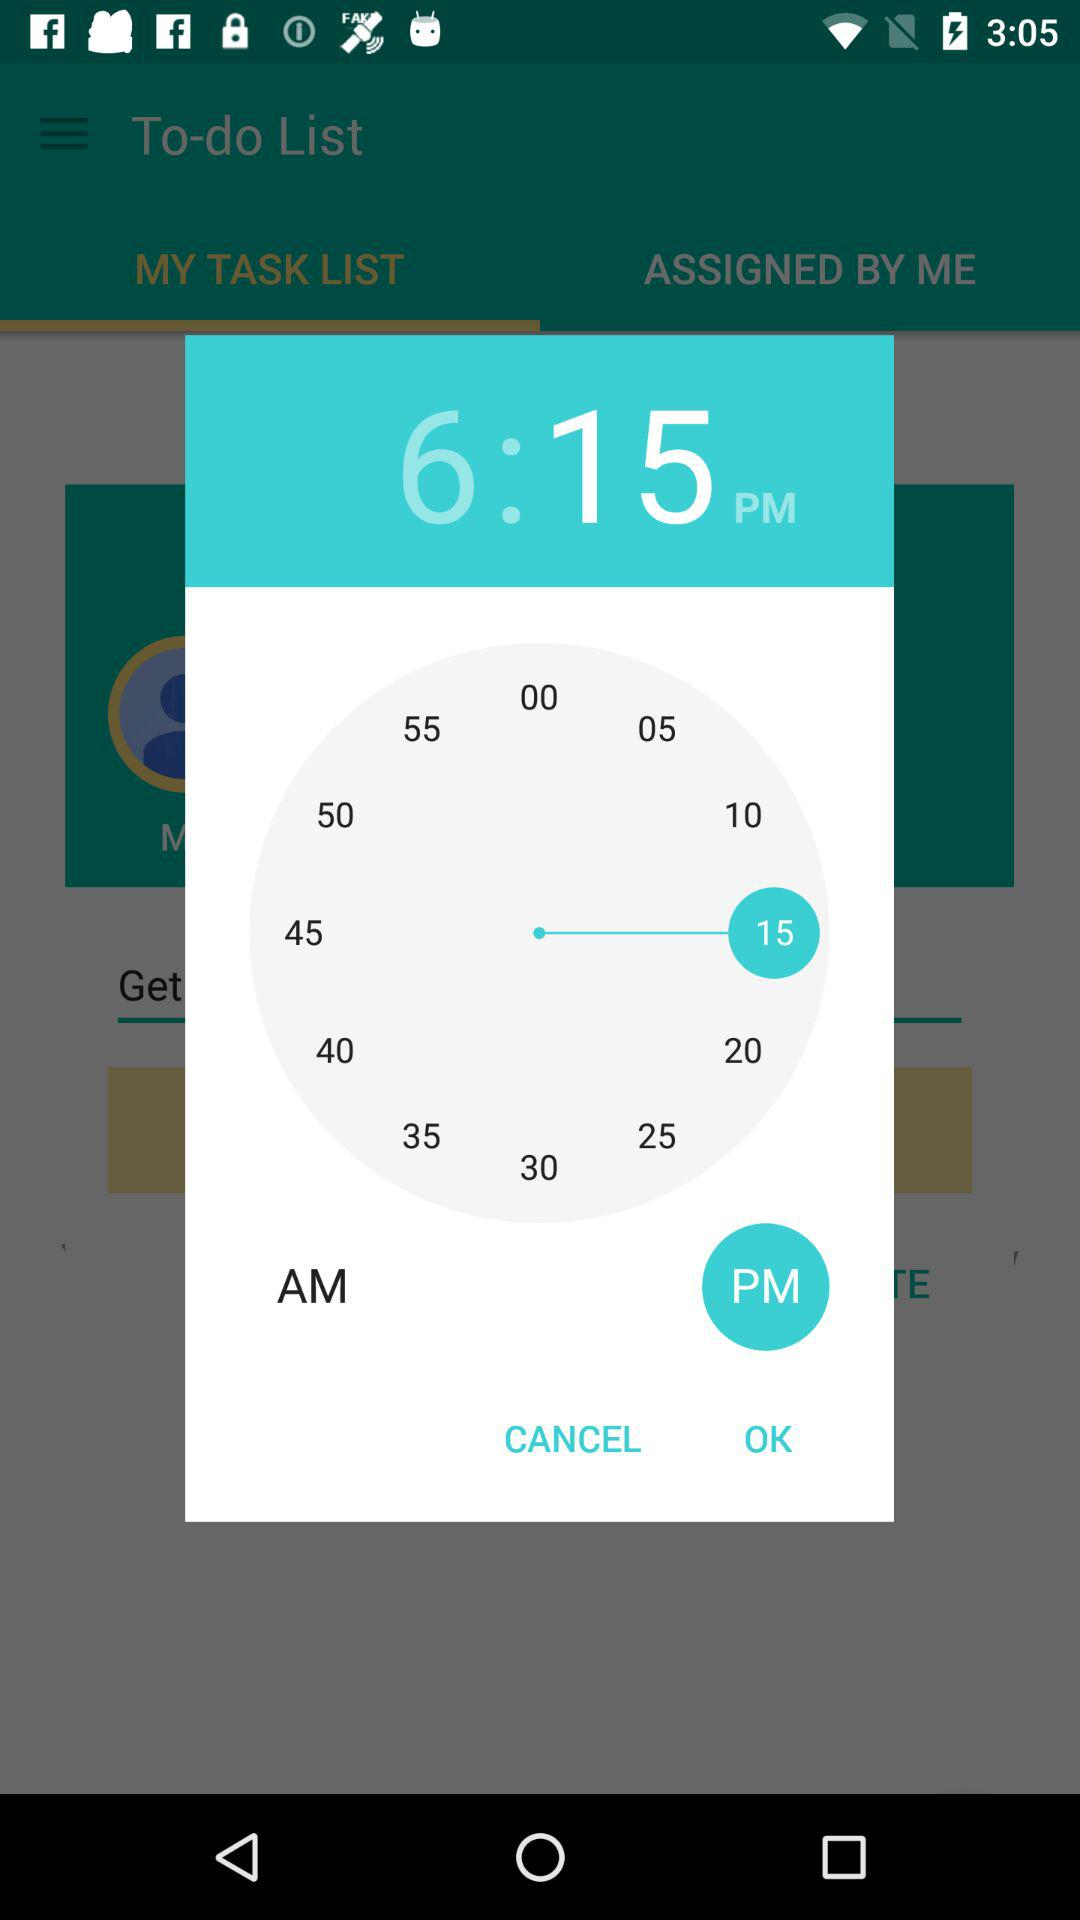How many more minutes are there between 6 and 15?
Answer the question using a single word or phrase. 9 